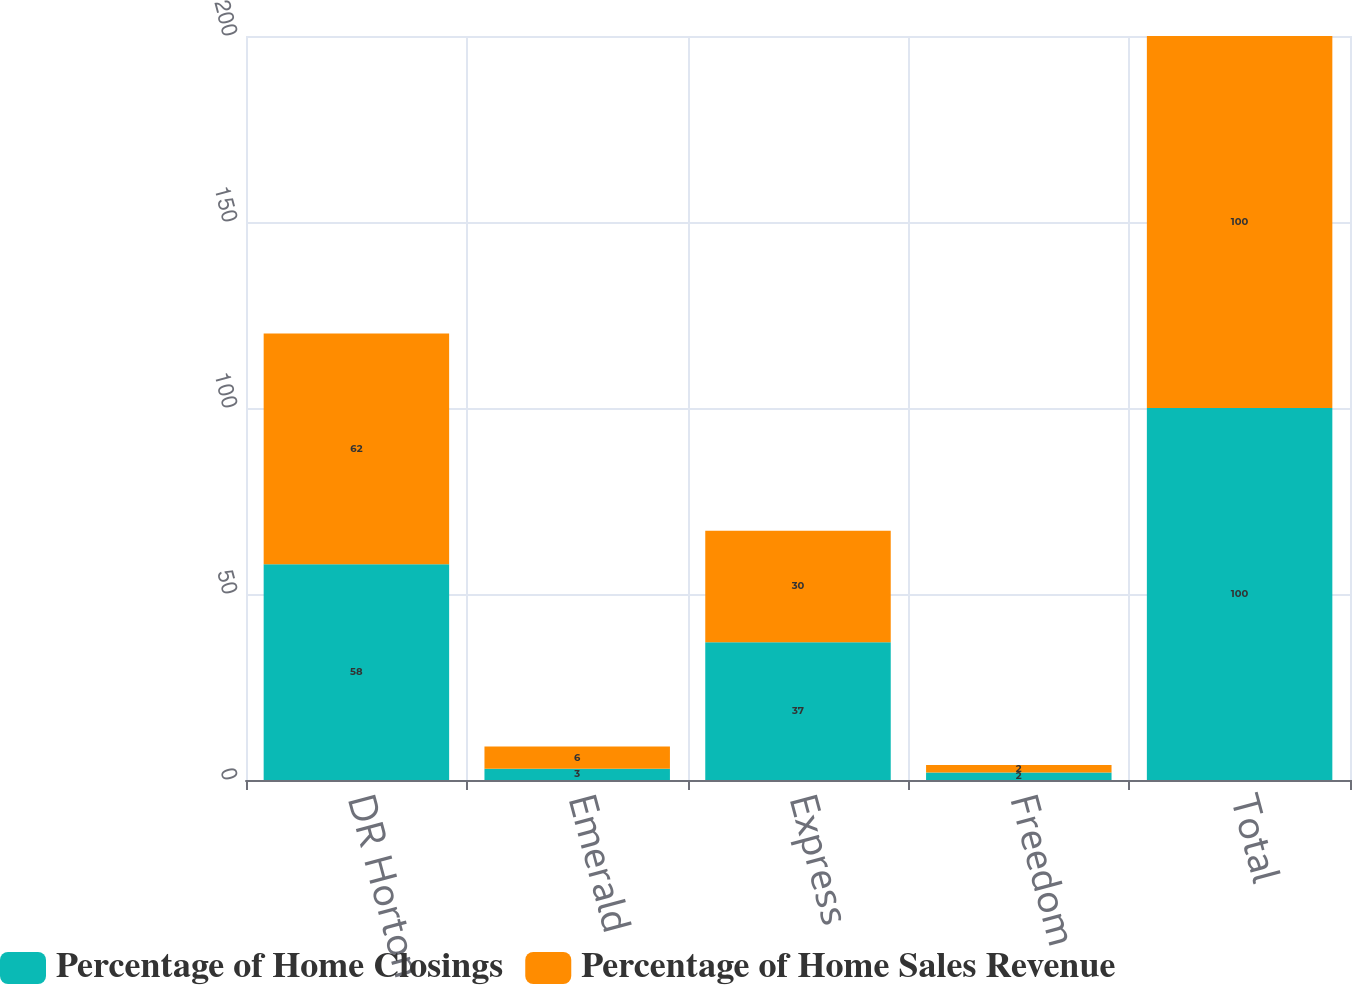Convert chart. <chart><loc_0><loc_0><loc_500><loc_500><stacked_bar_chart><ecel><fcel>DR Horton<fcel>Emerald<fcel>Express<fcel>Freedom<fcel>Total<nl><fcel>Percentage of Home Closings<fcel>58<fcel>3<fcel>37<fcel>2<fcel>100<nl><fcel>Percentage of Home Sales Revenue<fcel>62<fcel>6<fcel>30<fcel>2<fcel>100<nl></chart> 